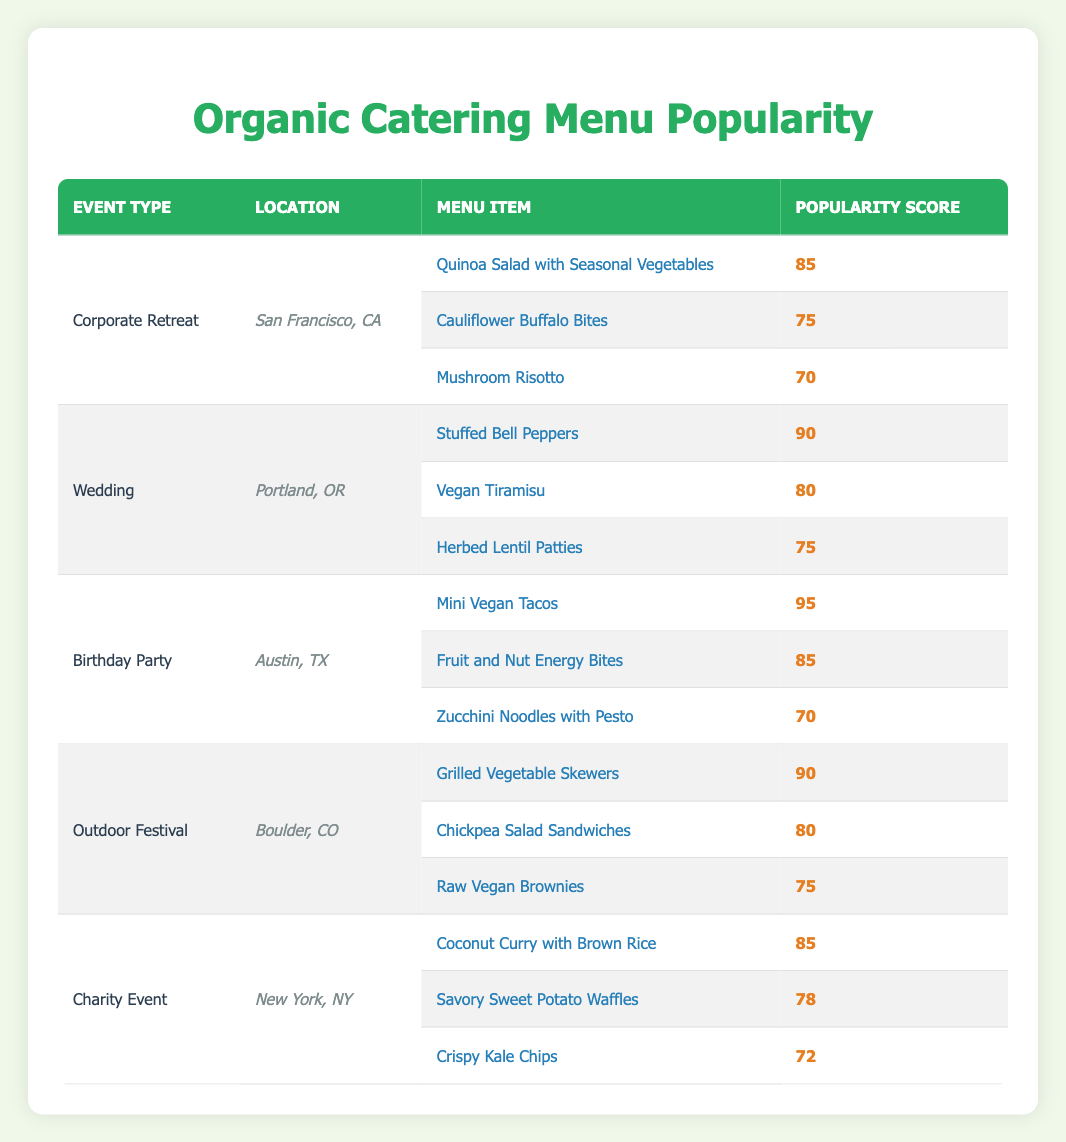What is the most popular menu item at a Birthday Party in Austin, TX? The most popular menu item is listed at the top of the Birthday Party section, which is "Mini Vegan Tacos" with a popularity score of 95.
Answer: Mini Vegan Tacos Which event type has the highest popularity score for its top menu item? To find this, we compare the highest popularity scores of the top menu items for each event type: Corporate Retreat (85), Wedding (90), Birthday Party (95), Outdoor Festival (90), Charity Event (85). The highest score is from the Birthday Party at 95.
Answer: Birthday Party Is "Chickpea Salad Sandwiches" more popular than "Crispy Kale Chips"? We compare the popularity scores: "Chickpea Salad Sandwiches" has a score of 80, while "Crispy Kale Chips" has a score of 72. Since 80 is greater than 72, it is true that Chickpea Salad Sandwiches are more popular.
Answer: Yes What is the average popularity score of the menu items for the Wedding event? The popularity scores for Wedding are: 90, 80, and 75. The sum is 90 + 80 + 75 = 245. There are 3 items, so the average score is 245 / 3 = 81.67.
Answer: 81.67 Which location features the least popular menu item and what is its score? To find this, we look at the lowest popularity scores across all events. The lowest score is "Crispy Kale Chips" with a score of 72 from the Charity Event in New York, NY.
Answer: 72 (Crispy Kale Chips) What is the total popularity score of menu items at the Outdoor Festival? The menu items at the Outdoor Festival have the following scores: Grilled Vegetable Skewers (90), Chickpea Salad Sandwiches (80), Raw Vegan Brownies (75). Adding these scores gives 90 + 80 + 75 = 245.
Answer: 245 How many menu items have a popularity score of 75 or higher in the Corporate Retreat event? The menu items in the Corporate Retreat are Quinoa Salad with Seasonal Vegetables (85), Cauliflower Buffalo Bites (75), and Mushroom Risotto (70). The scores 85 and 75 are both 75 or higher, so there are 2 items.
Answer: 2 Is "Stuffed Bell Peppers" the least popular item in the Wedding menu? In the Wedding segment, the popularity scores are: Stuffed Bell Peppers (90), Vegan Tiramisu (80), and Herbed Lentil Patties (75). Since 90 is higher than both 80 and 75, it is not the least popular item.
Answer: No Which event type has more menu items scored above 80, and how many are there? The Birthday Party has two items over 80 (Mini Vegan Tacos at 95 and Fruit and Nut Energy Bites at 85), while the Wedding has two as well (Stuffed Bell Peppers at 90 and Vegan Tiramisu at 80). Multiple event types share the same count, but they each have 2 items.
Answer: Both have 2 